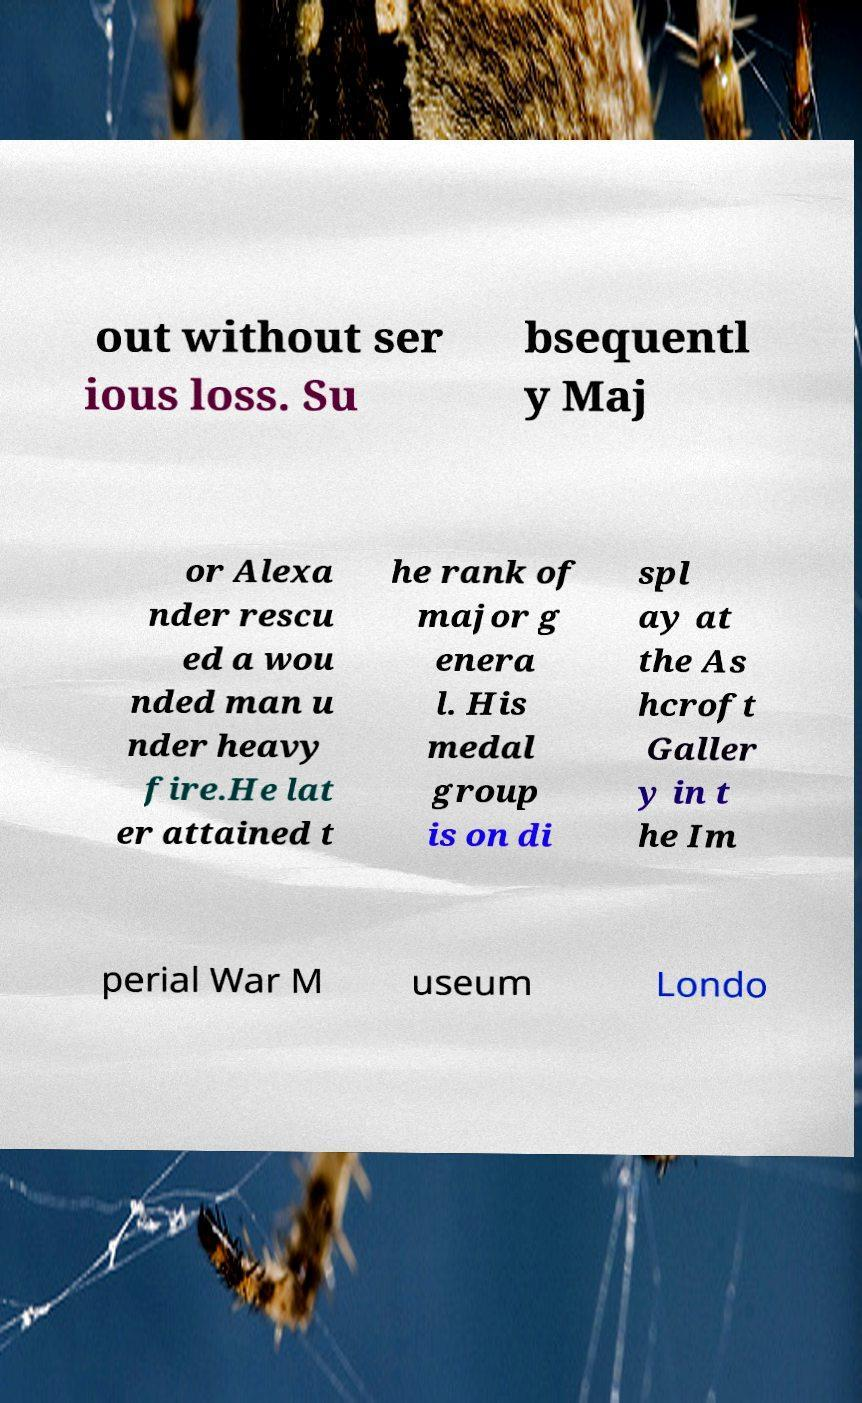Could you extract and type out the text from this image? out without ser ious loss. Su bsequentl y Maj or Alexa nder rescu ed a wou nded man u nder heavy fire.He lat er attained t he rank of major g enera l. His medal group is on di spl ay at the As hcroft Galler y in t he Im perial War M useum Londo 